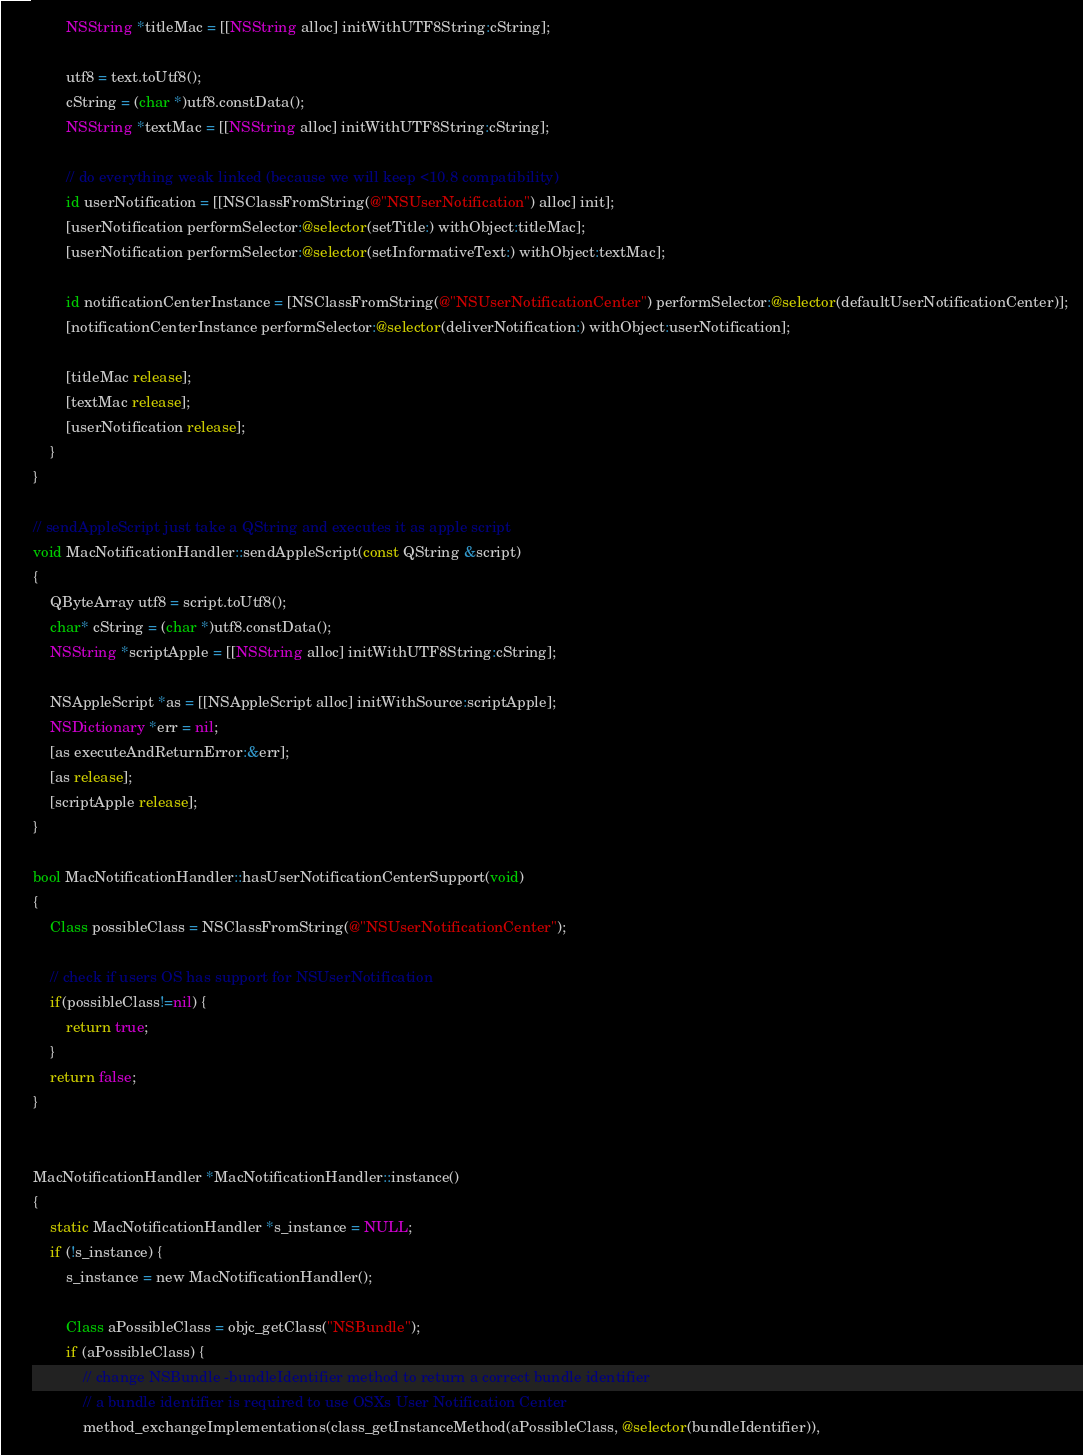<code> <loc_0><loc_0><loc_500><loc_500><_ObjectiveC_>        NSString *titleMac = [[NSString alloc] initWithUTF8String:cString];

        utf8 = text.toUtf8();
        cString = (char *)utf8.constData();
        NSString *textMac = [[NSString alloc] initWithUTF8String:cString];

        // do everything weak linked (because we will keep <10.8 compatibility)
        id userNotification = [[NSClassFromString(@"NSUserNotification") alloc] init];
        [userNotification performSelector:@selector(setTitle:) withObject:titleMac];
        [userNotification performSelector:@selector(setInformativeText:) withObject:textMac];

        id notificationCenterInstance = [NSClassFromString(@"NSUserNotificationCenter") performSelector:@selector(defaultUserNotificationCenter)];
        [notificationCenterInstance performSelector:@selector(deliverNotification:) withObject:userNotification];

        [titleMac release];
        [textMac release];
        [userNotification release];
    }
}

// sendAppleScript just take a QString and executes it as apple script
void MacNotificationHandler::sendAppleScript(const QString &script)
{
    QByteArray utf8 = script.toUtf8();
    char* cString = (char *)utf8.constData();
    NSString *scriptApple = [[NSString alloc] initWithUTF8String:cString];

    NSAppleScript *as = [[NSAppleScript alloc] initWithSource:scriptApple];
    NSDictionary *err = nil;
    [as executeAndReturnError:&err];
    [as release];
    [scriptApple release];
}

bool MacNotificationHandler::hasUserNotificationCenterSupport(void)
{
    Class possibleClass = NSClassFromString(@"NSUserNotificationCenter");

    // check if users OS has support for NSUserNotification
    if(possibleClass!=nil) {
        return true;
    }
    return false;
}


MacNotificationHandler *MacNotificationHandler::instance()
{
    static MacNotificationHandler *s_instance = NULL;
    if (!s_instance) {
        s_instance = new MacNotificationHandler();

        Class aPossibleClass = objc_getClass("NSBundle");
        if (aPossibleClass) {
            // change NSBundle -bundleIdentifier method to return a correct bundle identifier
            // a bundle identifier is required to use OSXs User Notification Center
            method_exchangeImplementations(class_getInstanceMethod(aPossibleClass, @selector(bundleIdentifier)),</code> 